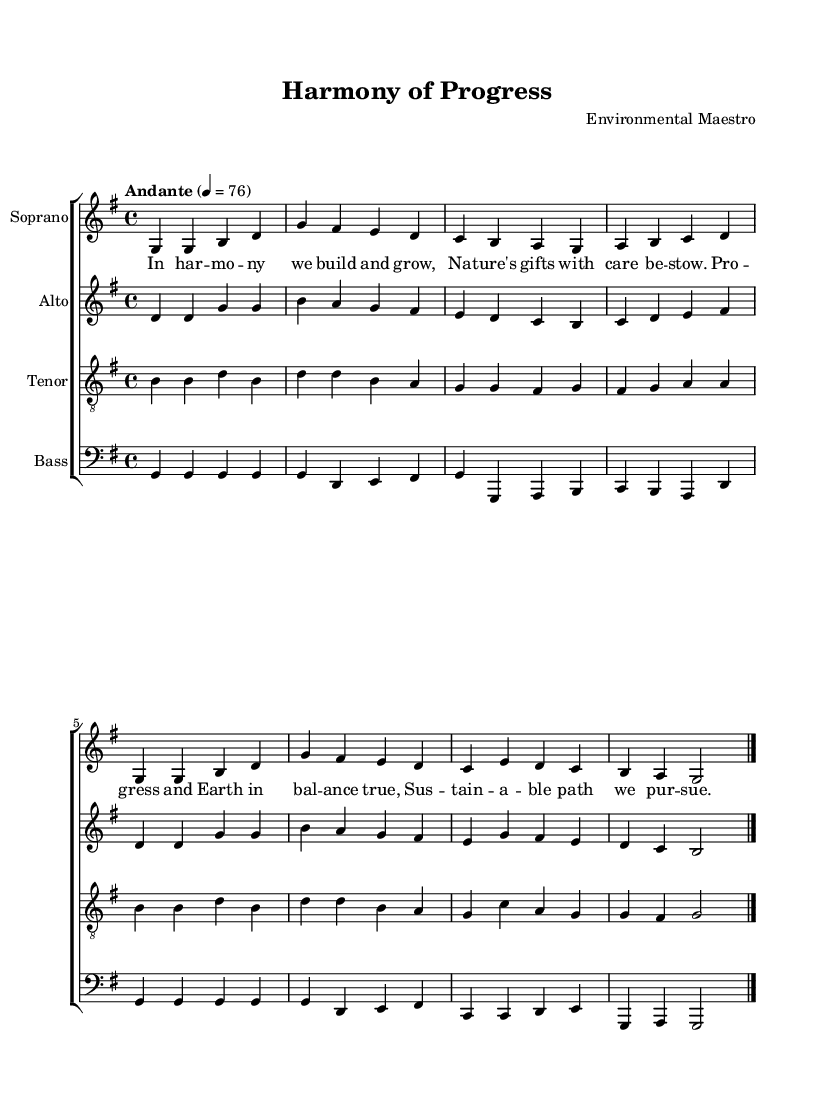What is the key signature of this music? The key signature shows one sharp, indicating the piece is in G major.
Answer: G major What is the time signature of this music? The time signature, found at the beginning of the score, is 4/4, indicating four beats per measure.
Answer: 4/4 What is the tempo marking for this piece? The tempo marking is "Andante," which indicates a moderately slow pace, typically between 76 to 108 beats per minute.
Answer: Andante How many voices are in the choir? The score includes four distinct voices: soprano, alto, tenor, and bass.
Answer: Four What is the first lyric of the piece? The first lyric is found in the verse section, which reads "In harmony we build and grow."
Answer: In harmony we build and grow Which voice has the melody during the first phrase? Analyzing the musical lines, the soprano voice has the highest notes, indicating it carries the melody in the first phrase.
Answer: Soprano What type of musical work is this? Given the structure of the score, instrumentation, and text, this piece is classified as a choral work.
Answer: Choral work 